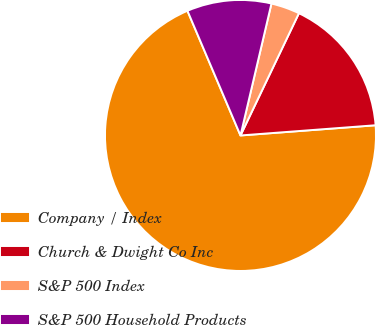Convert chart. <chart><loc_0><loc_0><loc_500><loc_500><pie_chart><fcel>Company / Index<fcel>Church & Dwight Co Inc<fcel>S&P 500 Index<fcel>S&P 500 Household Products<nl><fcel>69.8%<fcel>16.7%<fcel>3.43%<fcel>10.07%<nl></chart> 